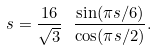Convert formula to latex. <formula><loc_0><loc_0><loc_500><loc_500>s = \frac { 1 6 } { \sqrt { 3 } } \ \frac { \sin ( \pi s / 6 ) } { \cos ( \pi s / 2 ) } .</formula> 